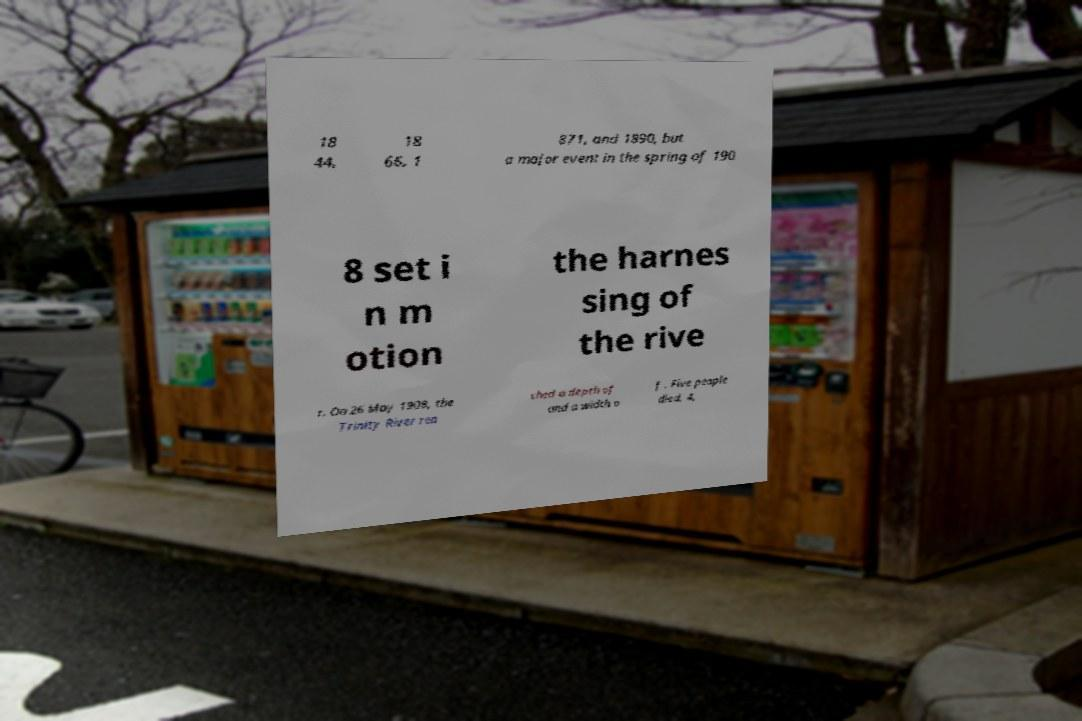Could you extract and type out the text from this image? 18 44, 18 66, 1 871, and 1890, but a major event in the spring of 190 8 set i n m otion the harnes sing of the rive r. On 26 May 1908, the Trinity River rea ched a depth of and a width o f . Five people died, 4, 